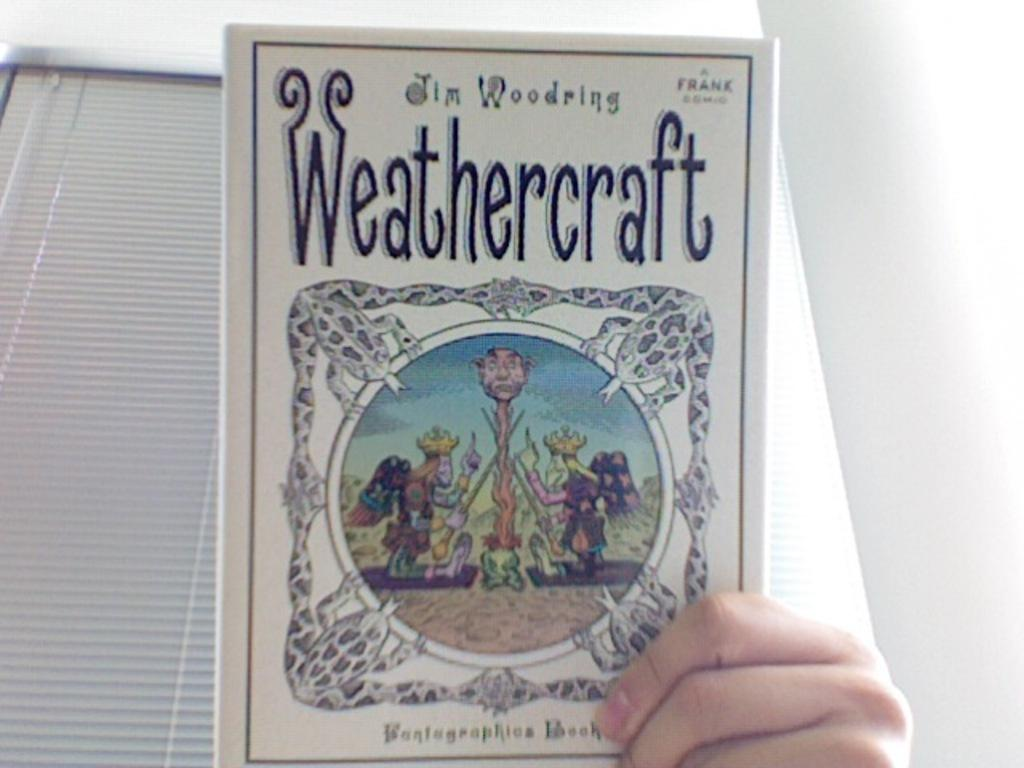<image>
Render a clear and concise summary of the photo. A hand holds up a white book with the title "Weathercraft." 